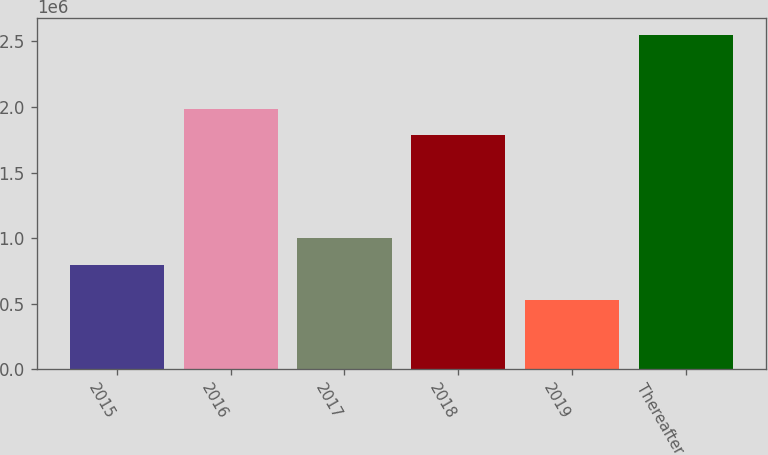<chart> <loc_0><loc_0><loc_500><loc_500><bar_chart><fcel>2015<fcel>2016<fcel>2017<fcel>2018<fcel>2019<fcel>Thereafter<nl><fcel>799630<fcel>1.98747e+06<fcel>1.00202e+06<fcel>1.78508e+06<fcel>529197<fcel>2.55305e+06<nl></chart> 